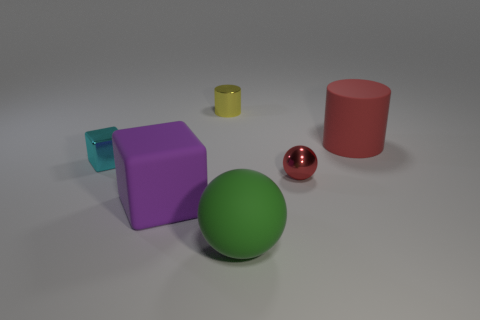What is the material of the green object?
Ensure brevity in your answer.  Rubber. What size is the thing that is the same color as the large matte cylinder?
Keep it short and to the point. Small. There is a purple rubber thing; is its shape the same as the metallic object to the left of the large purple rubber object?
Make the answer very short. Yes. The cylinder to the right of the cylinder to the left of the red thing behind the red ball is made of what material?
Your answer should be compact. Rubber. How many large green matte things are there?
Your answer should be compact. 1. How many gray things are either shiny cylinders or big rubber things?
Keep it short and to the point. 0. How many other objects are there of the same shape as the small cyan thing?
Ensure brevity in your answer.  1. There is a large thing that is on the left side of the green matte ball; does it have the same color as the tiny metallic object that is left of the tiny yellow cylinder?
Your answer should be compact. No. What number of big objects are either cylinders or cyan objects?
Provide a short and direct response. 1. The matte object that is the same shape as the small cyan metallic object is what size?
Your answer should be compact. Large. 